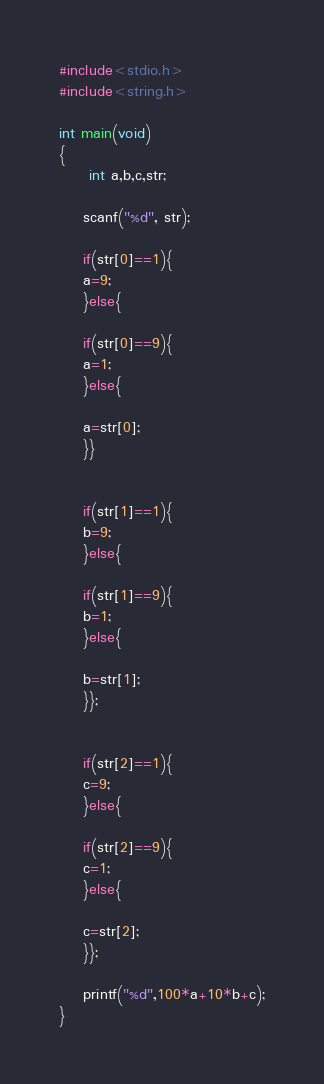Convert code to text. <code><loc_0><loc_0><loc_500><loc_500><_C_>#include<stdio.h>
#include<string.h>

int main(void)
{
     int a,b,c,str;

	scanf("%d", str);

	if(str[0]==1){
	a=9;
	}else{
	
	if(str[0]==9){
	a=1;
	}else{
	
	a=str[0];
	}}

	
	if(str[1]==1){
	b=9;
	}else{
	
	if(str[1]==9){
	b=1;
	}else{
	
	b=str[1];
	}};


	if(str[2]==1){
	c=9;
	}else{
	
	if(str[2]==9){
	c=1;
	}else{
	
	c=str[2];
	}};

	printf("%d",100*a+10*b+c);
}</code> 